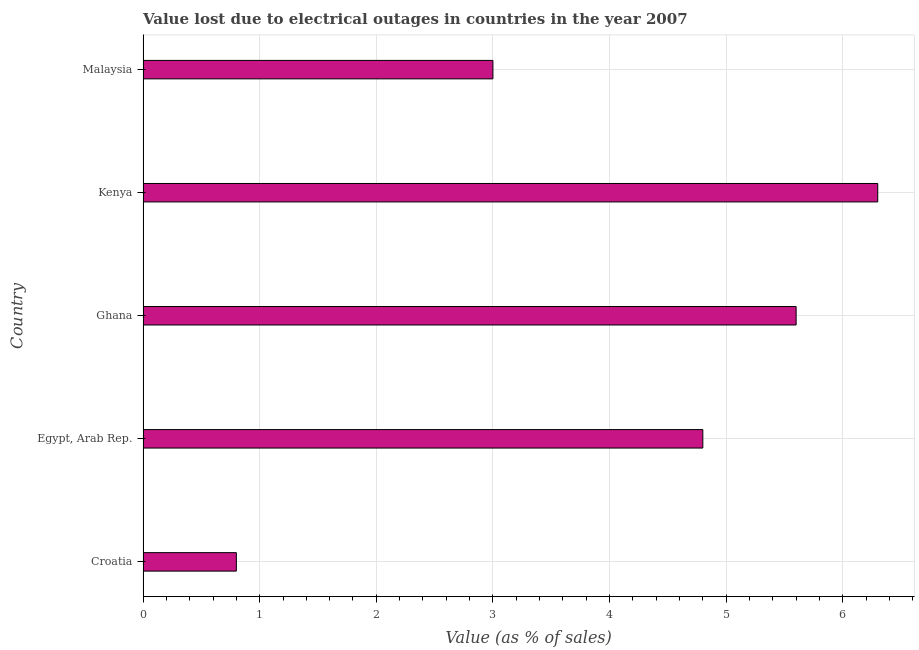Does the graph contain any zero values?
Offer a very short reply. No. Does the graph contain grids?
Your response must be concise. Yes. What is the title of the graph?
Ensure brevity in your answer.  Value lost due to electrical outages in countries in the year 2007. What is the label or title of the X-axis?
Ensure brevity in your answer.  Value (as % of sales). What is the label or title of the Y-axis?
Make the answer very short. Country. What is the value lost due to electrical outages in Egypt, Arab Rep.?
Provide a succinct answer. 4.8. Across all countries, what is the minimum value lost due to electrical outages?
Your answer should be compact. 0.8. In which country was the value lost due to electrical outages maximum?
Your response must be concise. Kenya. In which country was the value lost due to electrical outages minimum?
Provide a succinct answer. Croatia. What is the sum of the value lost due to electrical outages?
Keep it short and to the point. 20.5. What is the ratio of the value lost due to electrical outages in Ghana to that in Kenya?
Your response must be concise. 0.89. Is the value lost due to electrical outages in Croatia less than that in Egypt, Arab Rep.?
Your answer should be compact. Yes. What is the difference between the highest and the lowest value lost due to electrical outages?
Your response must be concise. 5.5. In how many countries, is the value lost due to electrical outages greater than the average value lost due to electrical outages taken over all countries?
Make the answer very short. 3. How many bars are there?
Your answer should be compact. 5. Are all the bars in the graph horizontal?
Offer a terse response. Yes. What is the difference between two consecutive major ticks on the X-axis?
Ensure brevity in your answer.  1. Are the values on the major ticks of X-axis written in scientific E-notation?
Provide a succinct answer. No. What is the Value (as % of sales) of Egypt, Arab Rep.?
Your answer should be compact. 4.8. What is the Value (as % of sales) of Kenya?
Make the answer very short. 6.3. What is the difference between the Value (as % of sales) in Croatia and Egypt, Arab Rep.?
Provide a succinct answer. -4. What is the difference between the Value (as % of sales) in Croatia and Ghana?
Give a very brief answer. -4.8. What is the difference between the Value (as % of sales) in Croatia and Kenya?
Your answer should be compact. -5.5. What is the difference between the Value (as % of sales) in Croatia and Malaysia?
Make the answer very short. -2.2. What is the difference between the Value (as % of sales) in Egypt, Arab Rep. and Ghana?
Your answer should be compact. -0.8. What is the difference between the Value (as % of sales) in Egypt, Arab Rep. and Kenya?
Provide a short and direct response. -1.5. What is the difference between the Value (as % of sales) in Egypt, Arab Rep. and Malaysia?
Keep it short and to the point. 1.8. What is the difference between the Value (as % of sales) in Ghana and Kenya?
Your response must be concise. -0.7. What is the difference between the Value (as % of sales) in Kenya and Malaysia?
Your response must be concise. 3.3. What is the ratio of the Value (as % of sales) in Croatia to that in Egypt, Arab Rep.?
Your response must be concise. 0.17. What is the ratio of the Value (as % of sales) in Croatia to that in Ghana?
Make the answer very short. 0.14. What is the ratio of the Value (as % of sales) in Croatia to that in Kenya?
Give a very brief answer. 0.13. What is the ratio of the Value (as % of sales) in Croatia to that in Malaysia?
Your answer should be compact. 0.27. What is the ratio of the Value (as % of sales) in Egypt, Arab Rep. to that in Ghana?
Provide a succinct answer. 0.86. What is the ratio of the Value (as % of sales) in Egypt, Arab Rep. to that in Kenya?
Make the answer very short. 0.76. What is the ratio of the Value (as % of sales) in Ghana to that in Kenya?
Your answer should be very brief. 0.89. What is the ratio of the Value (as % of sales) in Ghana to that in Malaysia?
Keep it short and to the point. 1.87. What is the ratio of the Value (as % of sales) in Kenya to that in Malaysia?
Your answer should be compact. 2.1. 